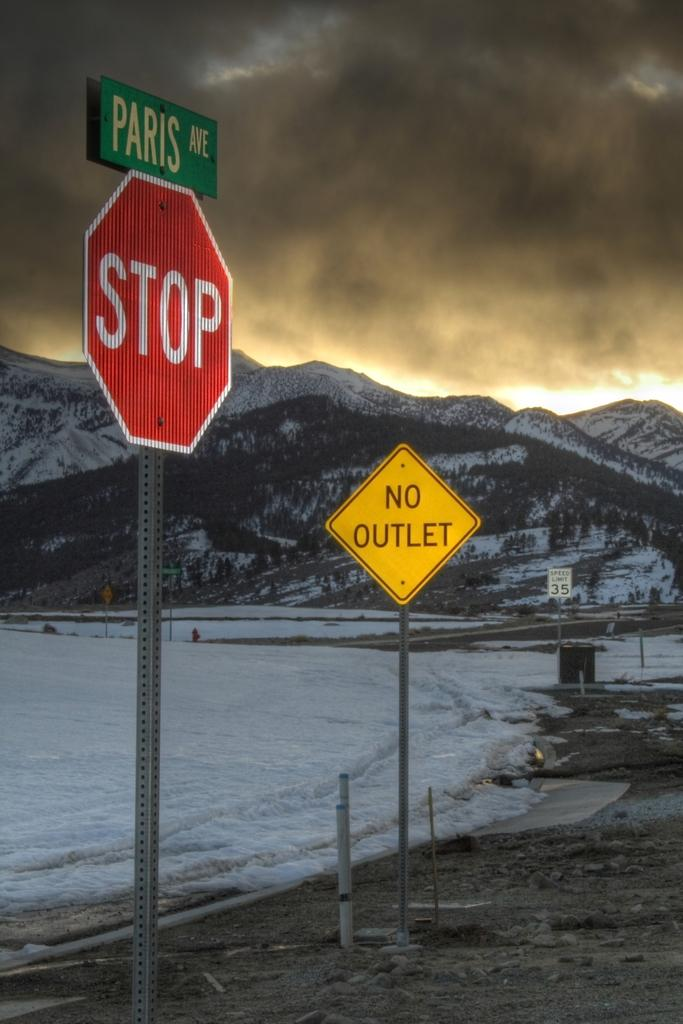<image>
Give a short and clear explanation of the subsequent image. a stop sign that has no outlet on it 